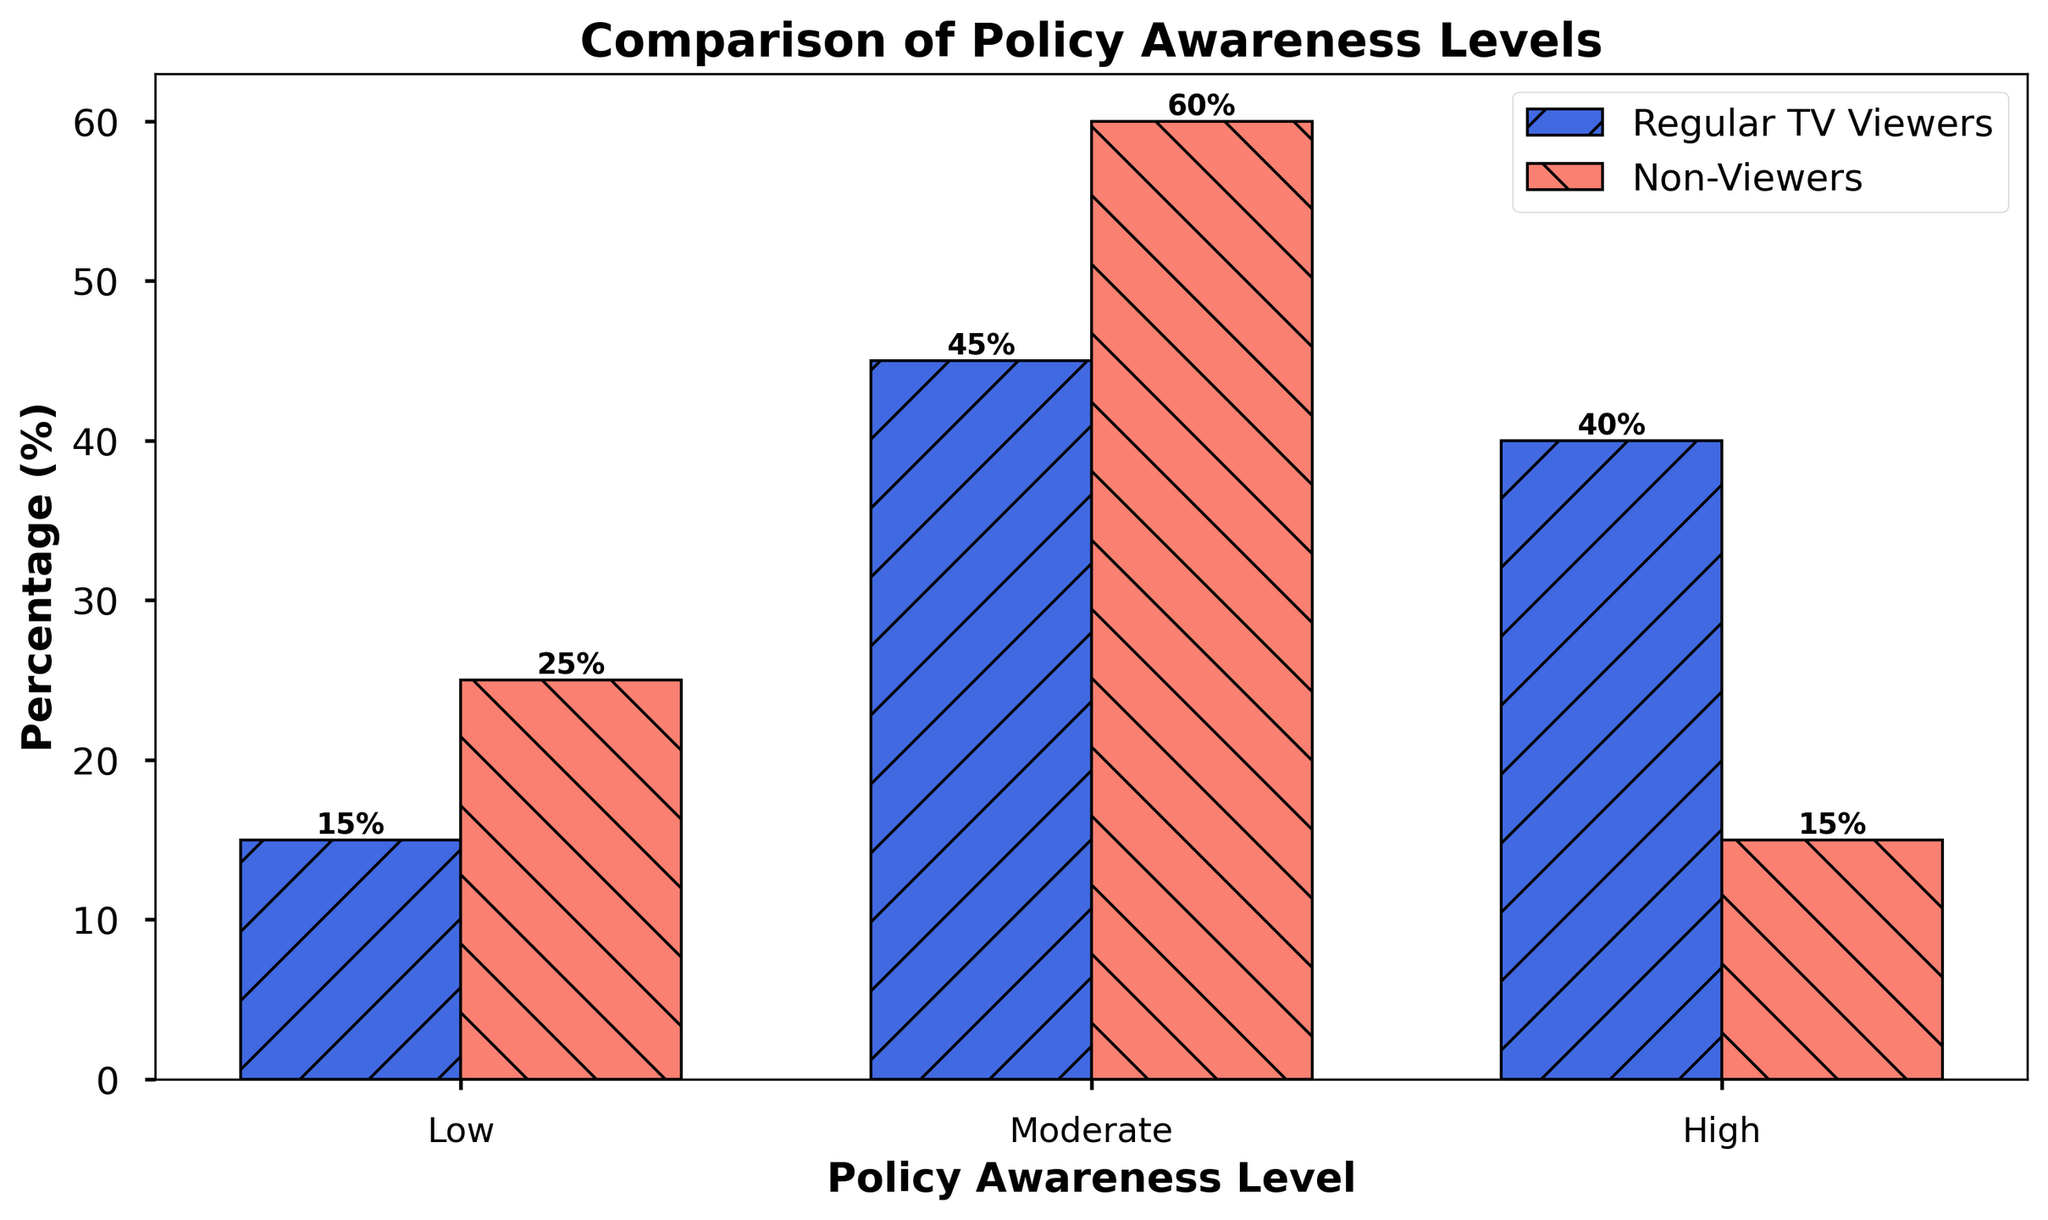Which group has the highest percentage of people with high policy awareness levels? The plot shows that Regular TV Viewers have a bar reaching 40% for high policy awareness levels, whereas Non-Viewers have a bar reaching only 15%. Therefore, Regular TV Viewers have the highest percentage of people with high policy awareness levels.
Answer: Regular TV Viewers Which group has the lowest percentage of people with low policy awareness levels? The plot shows that Regular TV Viewers have a bar reaching 15% for low policy awareness levels, whereas Non-Viewers have a bar reaching higher, at 25%. Therefore, Regular TV Viewers have the lowest percentage of people with low policy awareness levels.
Answer: Regular TV Viewers What is the total percentage of people with moderate and high policy awareness levels among Non-Viewers? Adding the percentages of moderate and high policy awareness levels for Non-Viewers, which are 60% and 15% respectively: 60% + 15% = 75%.
Answer: 75% How much greater is the percentage of Regular TV Viewers with high policy awareness compared to Non-Viewers with high policy awareness? The percentage of Regular TV Viewers with high policy awareness is 40%, and for Non-Viewers, it is 15%. The difference is 40% - 15% = 25%.
Answer: 25% Which group has a higher percentage of people with low policy awareness levels, and by how much? The plot shows that Non-Viewers have 25% at low policy awareness levels while Regular TV Viewers have 15%. The difference is 25% - 15% = 10%.
Answer: Non-Viewers by 10% Comparing both groups, how much greater is the sum of percentages of the moderate and high policy awareness levels for Regular TV Viewers compared to Non-Viewers? Regular TV Viewers: moderate (45%) + high (40%) = 85%. Non-Viewers: moderate (60%) + high (15%) = 75%. The difference is 85% - 75% = 10%.
Answer: 10% Which group has more uneven distribution across different policy awareness levels? The plot shows that Regular TV Viewers have percentages closer together (15%, 45%, 40%), while Non-Viewers have a more uneven distribution (25%, 60%, 15%).
Answer: Non-Viewers What is the combined percentage of people with low policy awareness for both groups? Adding the percentages of low policy awareness for both Regular TV Viewers (15%) and Non-Viewers (25%): 15% + 25% = 40%.
Answer: 40% For both groups, which policy awareness level category has the greatest combined percentage, and what is that value? Adding the percentages for low, moderate, and high categories for both groups:
- Low: 15% (Regular TV Viewers) + 25% (Non-Viewers) = 40%
- Moderate: 45% (Regular TV Viewers) + 60% (Non-Viewers) = 105%
- High: 40% (Regular TV Viewers) + 15% (Non-Viewers) = 55%
The moderate category has the greatest combined percentage, 105%.
Answer: Moderate, 105% 